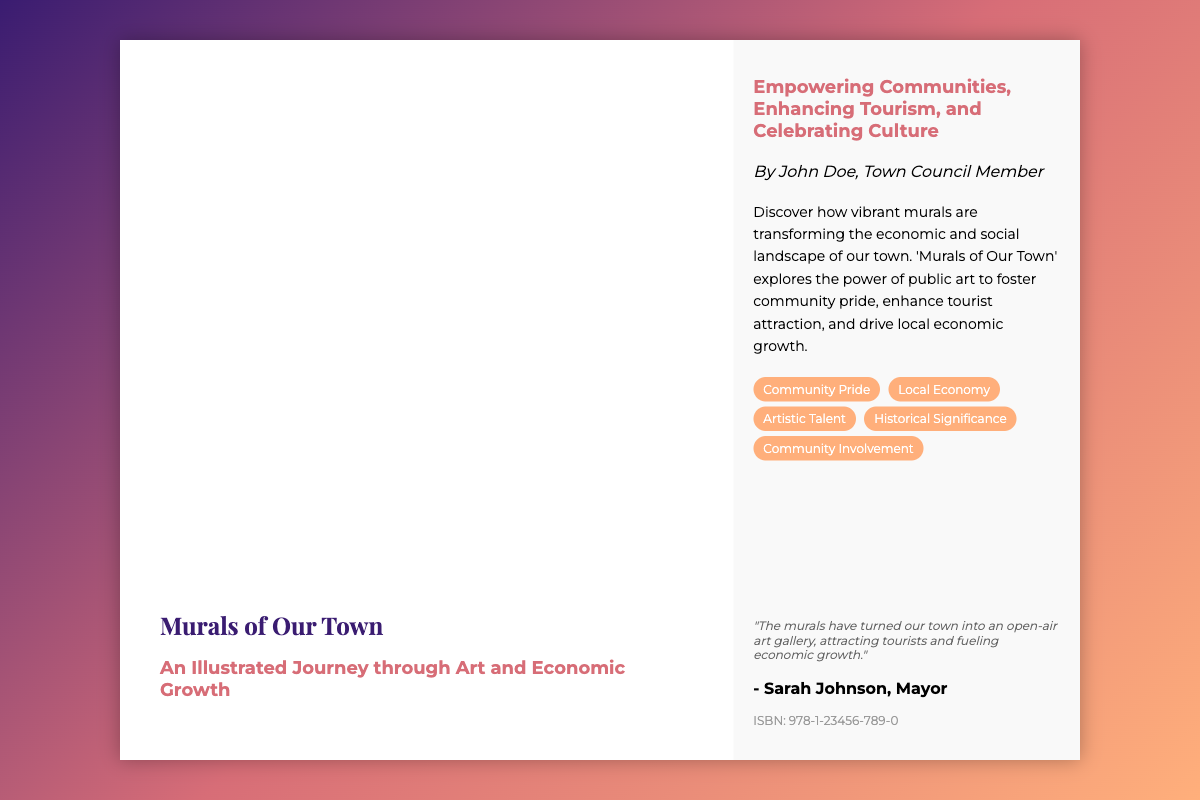what is the title of the book? The title is prominently displayed on the front cover of the document.
Answer: Murals of Our Town who is the author of the book? The author's name is mentioned in the back cover section of the document.
Answer: John Doe what is the central theme of the book? The themes are highlighted in the subtitle and description on the cover.
Answer: Art and Economic Growth what is the ISBN number of the book? The ISBN is provided on the back cover of the document.
Answer: 978-1-23456-789-0 which community leader is quoted in the document? The quote is credited to a prominent town official mentioned in the document.
Answer: Sarah Johnson how many topics are listed in the book description? The number of topics is determined by counting the topic labels shown in the document.
Answer: Five what role does the author hold in the town? The author's position is stated in the back cover under the author's name.
Answer: Town Council Member what does the quote emphasize about the murals? The quote reflects an opinion on the impact of murals on the town's economy and tourism.
Answer: Economic growth what kinds of aspects are highlighted in the topics section? The topics are summarized as significant areas of focus regarding the murals.
Answer: Community Pride, Local Economy, Artistic Talent, Historical Significance, Community Involvement 